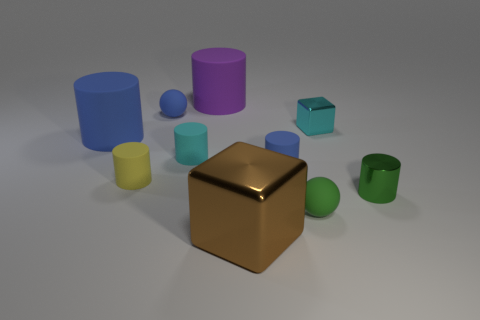Subtract 1 cylinders. How many cylinders are left? 5 Subtract all blue cylinders. How many cylinders are left? 4 Subtract all cyan cylinders. How many cylinders are left? 5 Subtract all gray cylinders. Subtract all brown cubes. How many cylinders are left? 6 Subtract all cylinders. How many objects are left? 4 Add 2 tiny green matte things. How many tiny green matte things are left? 3 Add 5 small yellow rubber cylinders. How many small yellow rubber cylinders exist? 6 Subtract 0 yellow cubes. How many objects are left? 10 Subtract all brown things. Subtract all big brown shiny cubes. How many objects are left? 8 